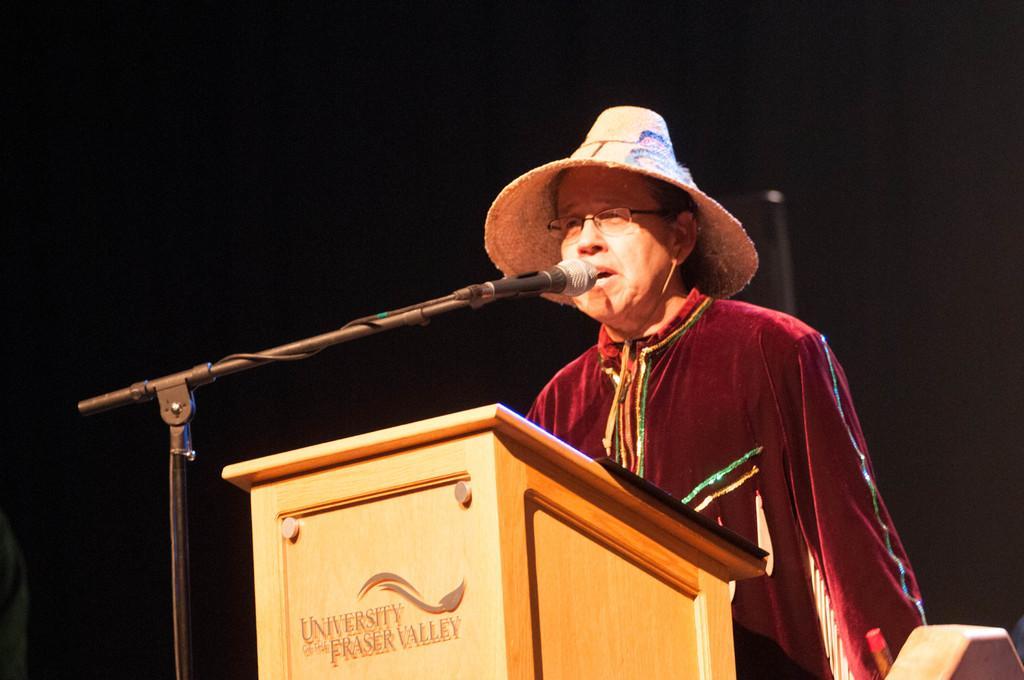Please provide a concise description of this image. In this image we can see a person wearing a hat, he is talking, in front of him there is a podium, also we can see the mic, and the stand, the background is dark. 